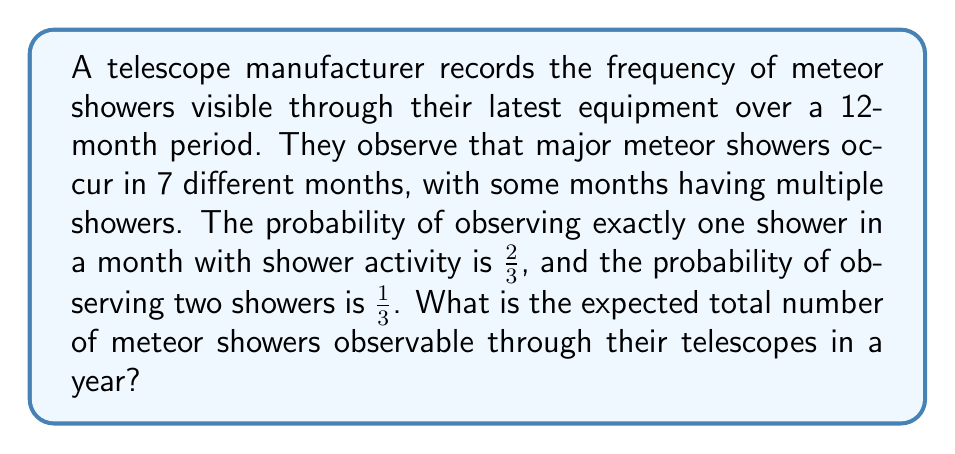Could you help me with this problem? Let's approach this step-by-step:

1) We know that meteor showers occur in 7 different months.

2) For each of these 7 months, there are two possible outcomes:
   - One shower with probability $\frac{2}{3}$
   - Two showers with probability $\frac{1}{3}$

3) Let's define a random variable $X_i$ for each month $i$ with shower activity:
   $$X_i = \begin{cases} 
   1 & \text{with probability } \frac{2}{3} \\
   2 & \text{with probability } \frac{1}{3}
   \end{cases}$$

4) The expected value of $X_i$ for each month is:
   $$E(X_i) = 1 \cdot \frac{2}{3} + 2 \cdot \frac{1}{3} = \frac{2}{3} + \frac{2}{3} = \frac{4}{3}$$

5) Since there are 7 months with shower activity, and the events in each month are independent, we can use the linearity of expectation. The total expected number of showers, let's call it $Y$, is:
   $$E(Y) = E(X_1 + X_2 + ... + X_7) = E(X_1) + E(X_2) + ... + E(X_7) = 7 \cdot \frac{4}{3}$$

6) Calculating the final result:
   $$E(Y) = 7 \cdot \frac{4}{3} = \frac{28}{3} = 9\frac{1}{3}$$

Therefore, the expected total number of meteor showers observable in a year is $9\frac{1}{3}$ or $\frac{28}{3}$.
Answer: $\frac{28}{3}$ 